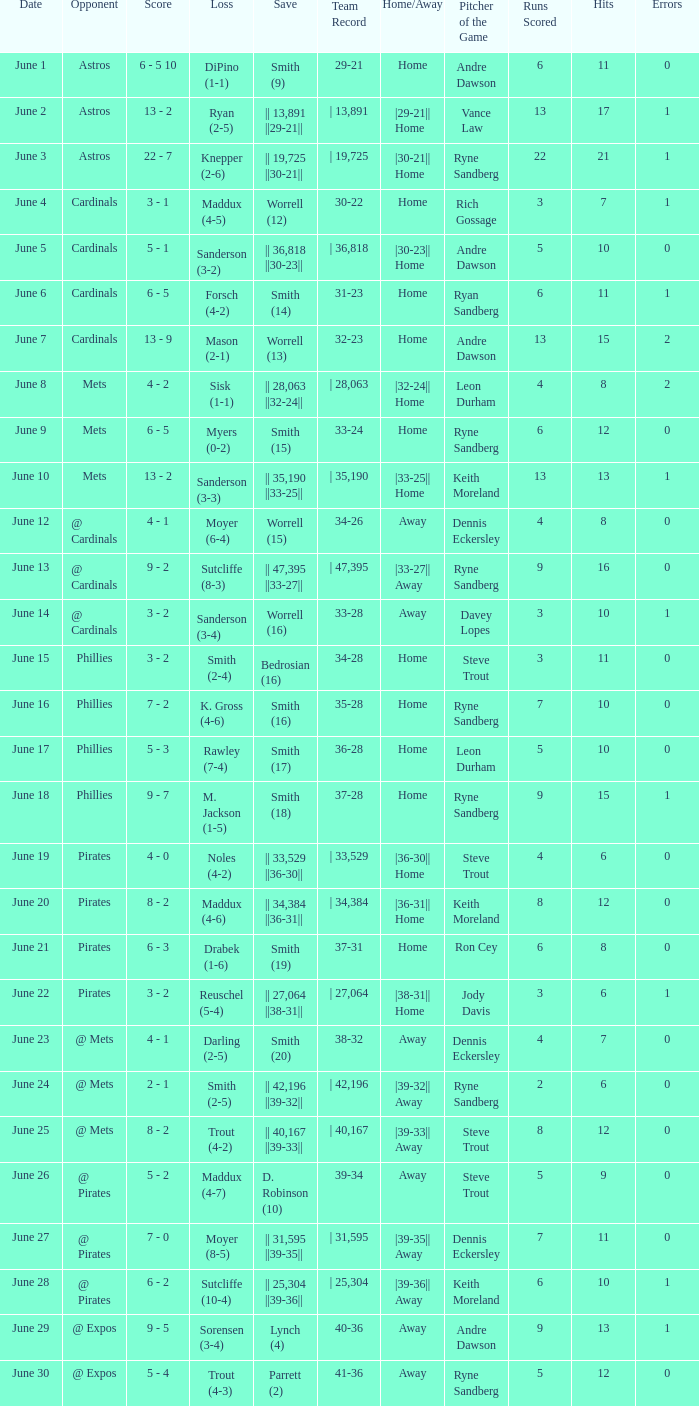Which day witnessed a trout loss (4-2) for the chicago cubs? June 25. 